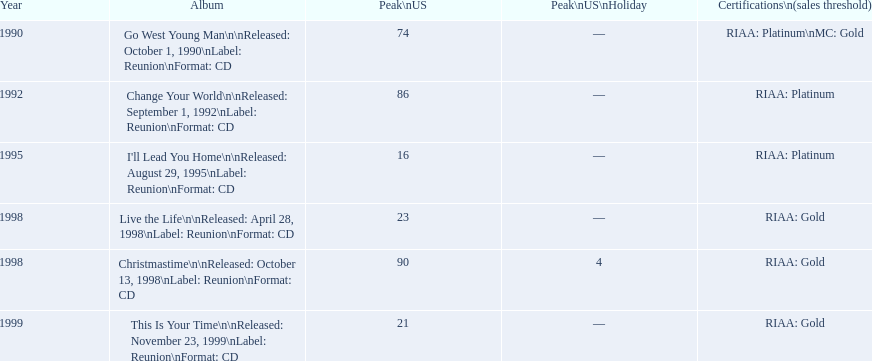What year comes after 1995? 1998. 